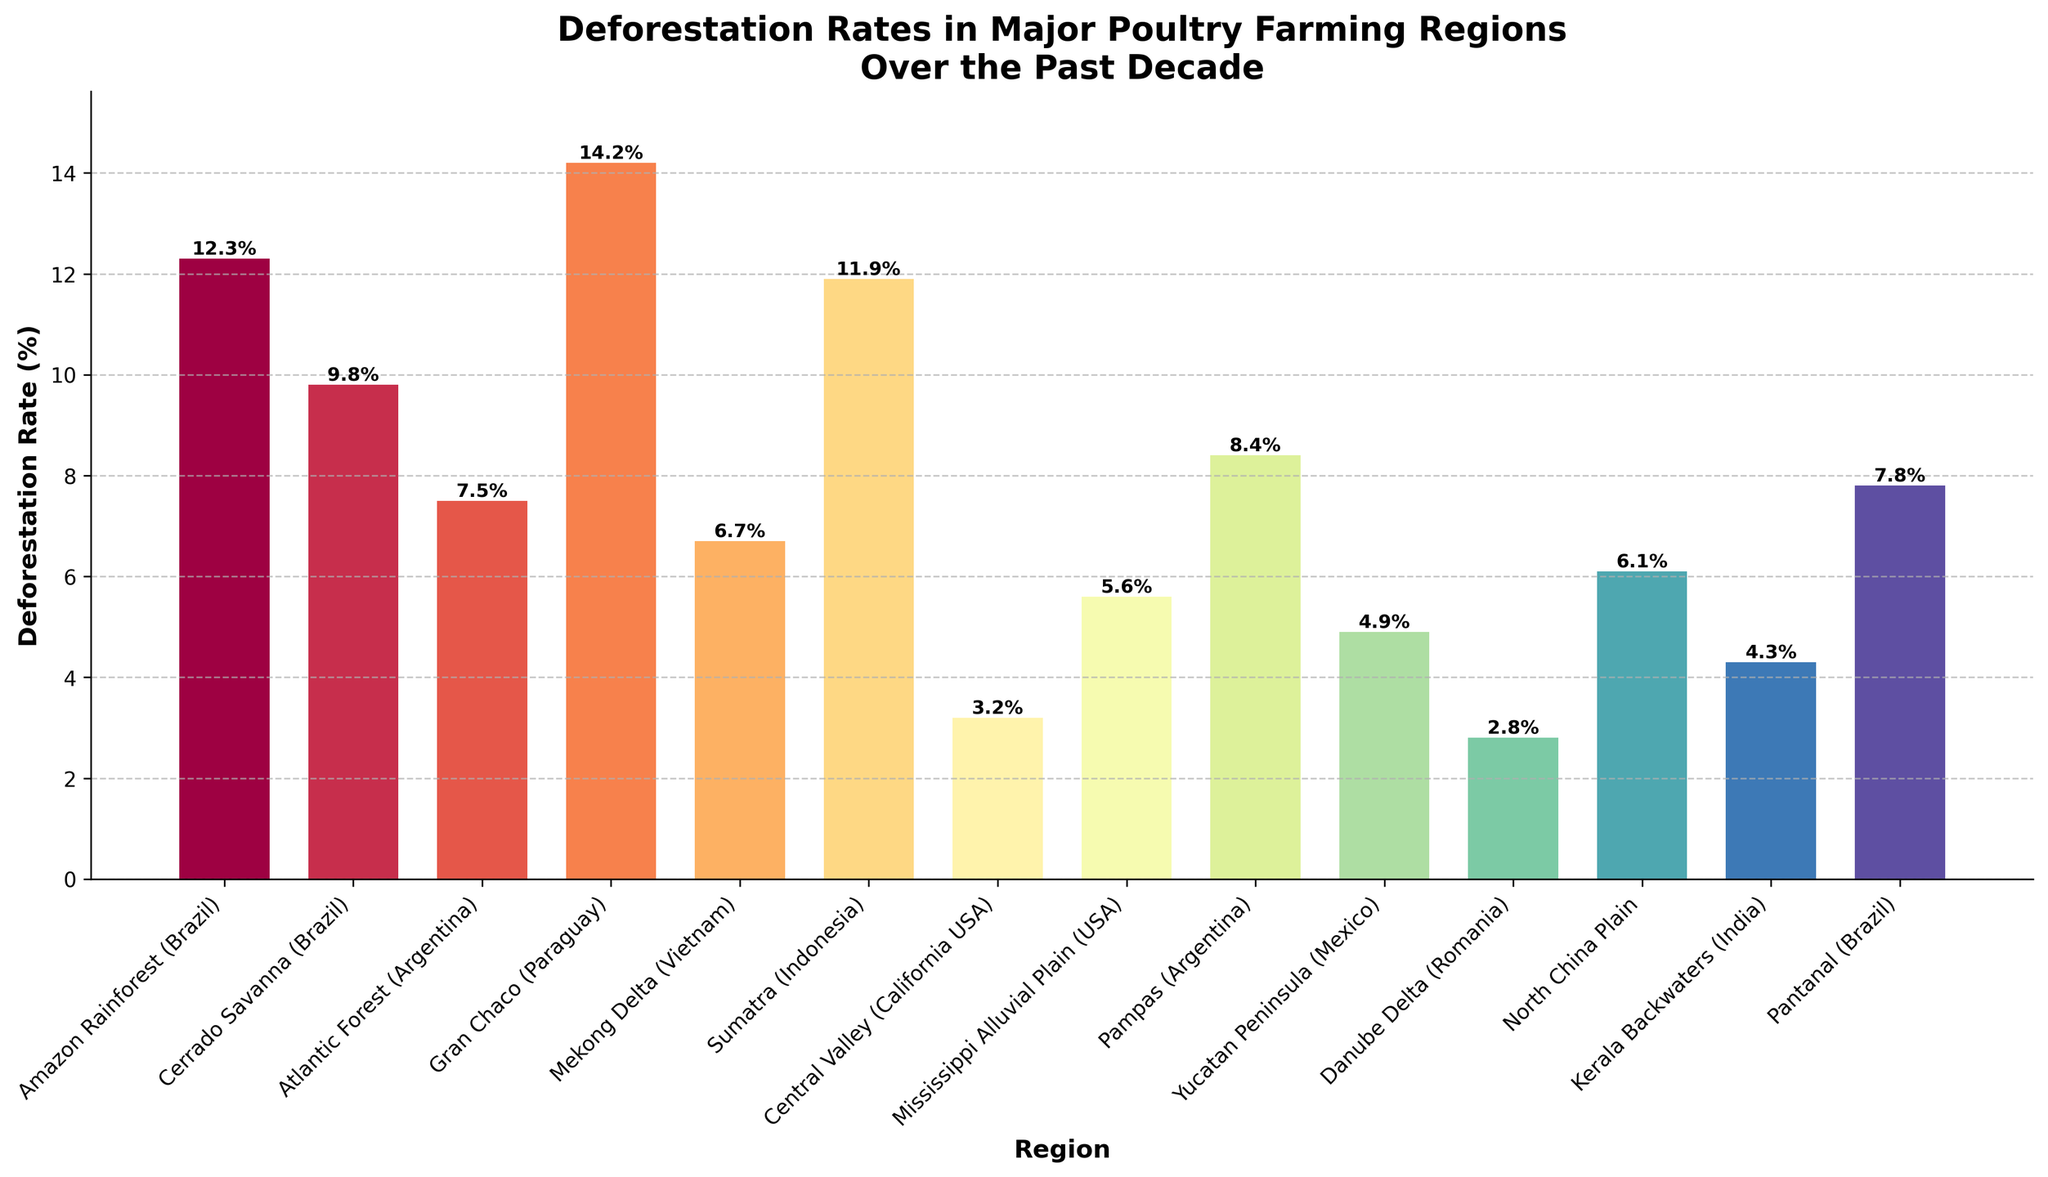What region has the highest deforestation rate? Identify the tallest bar on the chart; it represents the region with the highest deforestation rate. The Gran Chaco (Paraguay) has the tallest bar.
Answer: Gran Chaco (Paraguay) Which region has the lowest deforestation rate? Identify the shortest bar on the chart; it indicates the region with the lowest deforestation rate. The Danube Delta (Romania) has the shortest bar.
Answer: Danube Delta (Romania) What is the average deforestation rate across all regions? Add up all deforestation rates and divide by the number of regions. The sum is 105.5% across 14 regions, so the average is 105.5 / 14 ≈ 7.54%.
Answer: 7.54% How much higher is the deforestation rate in the Amazon Rainforest (Brazil) compared to the Mississippi Alluvial Plain (USA)? Subtract the deforestation rate of the Mississippi Alluvial Plain (5.6%) from the Amazon Rainforest (12.3%). 12.3% - 5.6% = 6.7%.
Answer: 6.7% Which regions have a deforestation rate greater than 10%? Look for bars that have heights exceeding the 10% mark. The regions are Amazon Rainforest (Brazil), Gran Chaco (Paraguay), and Sumatra (Indonesia).
Answer: Amazon Rainforest (Brazil), Gran Chaco (Paraguay), Sumatra (Indonesia) How does the deforestation rate in the Pantanal (Brazil) compare to the Pampas (Argentina)? Compare the heights of the bars for Pantanal (7.8%) and Pampas (8.4%). The Pampas has a slightly higher deforestation rate than the Pantanal.
Answer: Pampas (Argentina) has a higher rate What is the difference in deforestation rates between the Cerrado Savanna (Brazil) and North China Plain? Subtract the deforestation rate of North China Plain (6.1%) from Cerrado Savanna (9.8%). 9.8% - 6.1% = 3.7%.
Answer: 3.7% Which region in the USA has a lower deforestation rate, Central Valley (California) or Mississippi Alluvial Plain (USA)? Compare the heights of the bars for Central Valley (3.2%) and Mississippi Alluvial Plain (5.6%). The Central Valley has a lower deforestation rate.
Answer: Central Valley (California USA) How many regions have a deforestation rate below 5%? Count the bars with heights below the 5% mark. The regions are Danube Delta (Romania), Central Valley (California USA), and Yucatan Peninsula (Mexico), totaling 3 regions.
Answer: 3 What is the total deforestation rate of the four Brazilian regions combined? Sum the deforestation rates of Amazon Rainforest (12.3%), Cerrado Savanna (9.8%), Pantanal (7.8%), and Atlantic Forest (7.5%). 12.3 + 9.8 + 7.8 + 7.5 = 37.4%.
Answer: 37.4% 